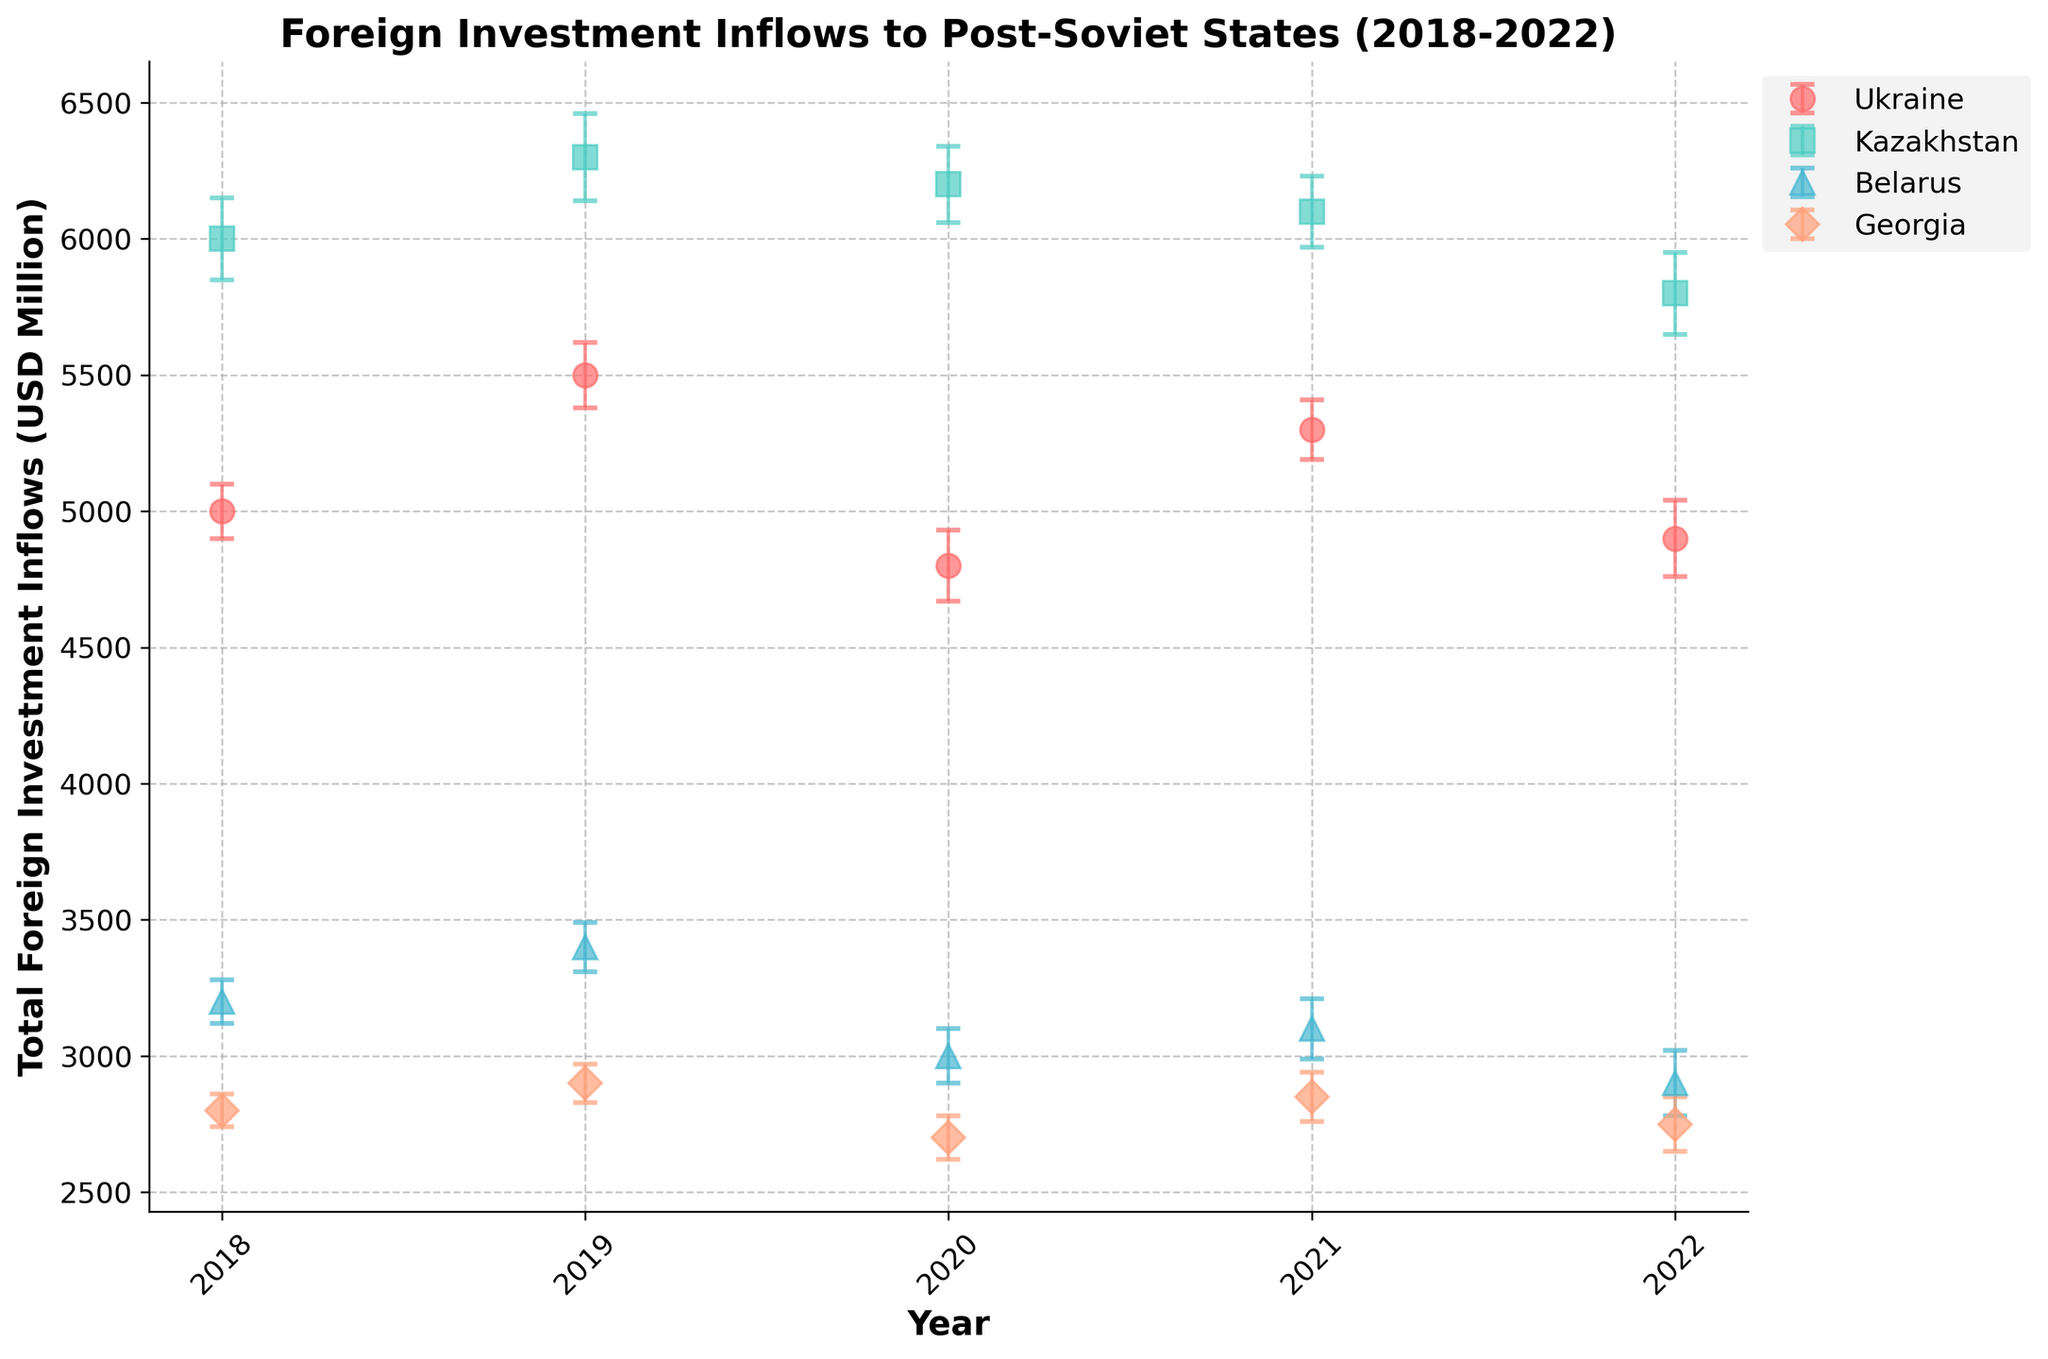What is the title of the figure? The title of the figure is clearly mentioned at the top. It states the subject and time period of the data.
Answer: Foreign Investment Inflows to Post-Soviet States (2018-2022) Which year had the highest total foreign investment inflows for Ukraine? Referencing the figure, look for the highest dot for Ukraine and check the corresponding year on the x-axis.
Answer: 2019 In which year did Belarus have the lowest foreign investment inflows? Identify the lowest dot for Belarus and match it to the year on the x-axis.
Answer: 2022 How much was the error margin for Kazakhstan in 2020? Check the length of the error bars for Kazakhstan in 2020, the figure legend will guide you.
Answer: 140 million USD Which country showed the most consistent foreign investment inflows over the years? Assess the fluctuation of the dots for each country; the country with the least variation/difference between the highest and lowest points will be the most consistent.
Answer: Georgia What is the difference in total foreign investment inflows between 2018 and 2022 for Kazakhstan? Find the values for Kazakhstan in 2018 and 2022, then subtract the 2022 value from the 2018 value.
Answer: 200 million USD Compare the foreign investment inflow trends of Ukraine and Georgia. What can be observed? Look at the upward or downward trends and the relative consistency of the dots/points for Ukraine and Georgia, the explanation would cover comparing both trends from 2018 to 2022.
Answer: Ukraine has more fluctuation, while Georgia is more consistent Which country experienced the largest drop in foreign investment inflows from 2021 to 2022? Calculate the difference in inflows for each country between these years and identify the largest.
Answer: Kazakhstan Between 2018 and 2022, which sector in Ukraine consistently received the highest foreign investment? Based on the data and corresponding colors/labels in the figure, track which sector remained the highest for Ukraine across the years.
Answer: Energy Sector 